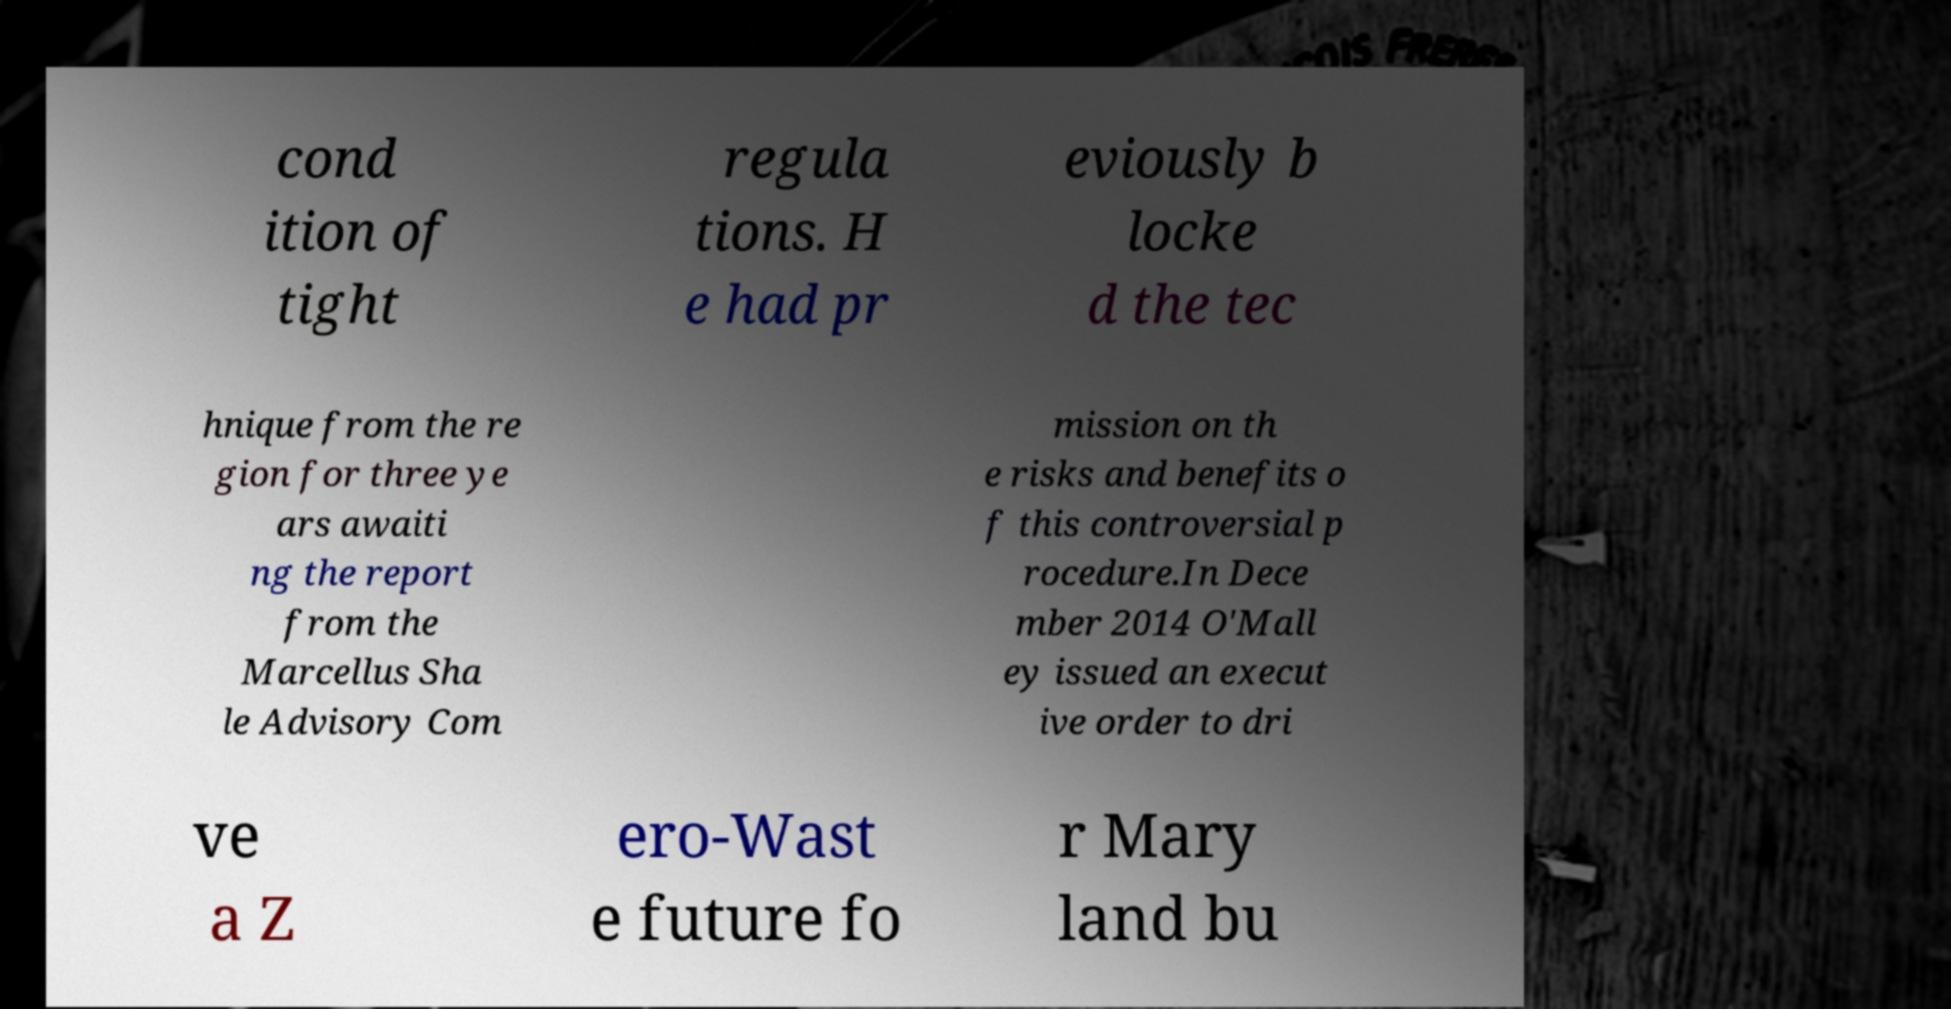There's text embedded in this image that I need extracted. Can you transcribe it verbatim? cond ition of tight regula tions. H e had pr eviously b locke d the tec hnique from the re gion for three ye ars awaiti ng the report from the Marcellus Sha le Advisory Com mission on th e risks and benefits o f this controversial p rocedure.In Dece mber 2014 O'Mall ey issued an execut ive order to dri ve a Z ero-Wast e future fo r Mary land bu 